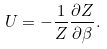Convert formula to latex. <formula><loc_0><loc_0><loc_500><loc_500>U = - \frac { 1 } { Z } \frac { \partial Z } { \partial \beta } .</formula> 